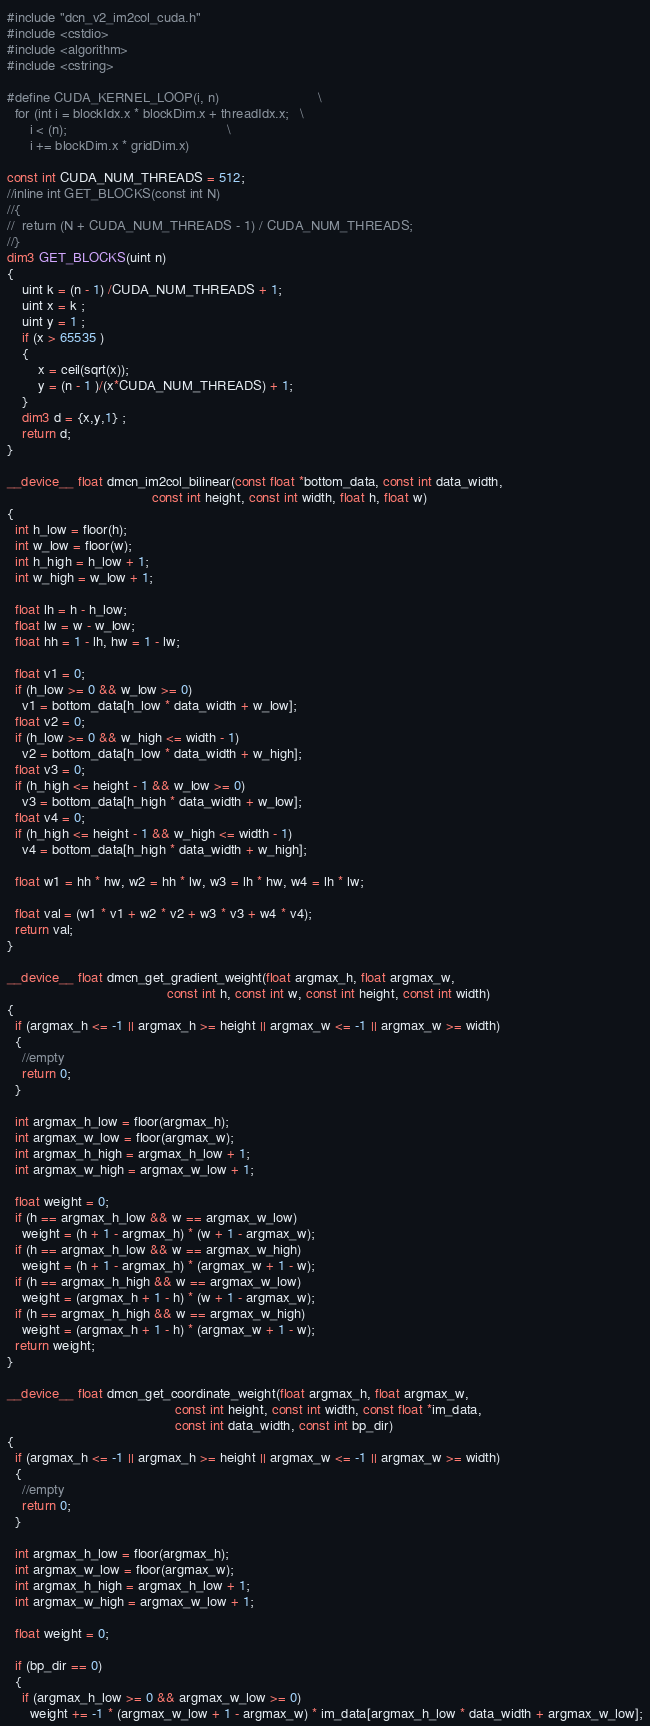Convert code to text. <code><loc_0><loc_0><loc_500><loc_500><_Cuda_>#include "dcn_v2_im2col_cuda.h"
#include <cstdio>
#include <algorithm>
#include <cstring>

#define CUDA_KERNEL_LOOP(i, n)                          \
  for (int i = blockIdx.x * blockDim.x + threadIdx.x;   \
      i < (n);                                          \
      i += blockDim.x * gridDim.x)

const int CUDA_NUM_THREADS = 512;
//inline int GET_BLOCKS(const int N)
//{
//  return (N + CUDA_NUM_THREADS - 1) / CUDA_NUM_THREADS;
//}
dim3 GET_BLOCKS(uint n)
{
    uint k = (n - 1) /CUDA_NUM_THREADS + 1;
    uint x = k ;
    uint y = 1 ;
    if (x > 65535 )
    {
        x = ceil(sqrt(x));
        y = (n - 1 )/(x*CUDA_NUM_THREADS) + 1;
    }
    dim3 d = {x,y,1} ;
    return d;
}

__device__ float dmcn_im2col_bilinear(const float *bottom_data, const int data_width,
                                      const int height, const int width, float h, float w)
{
  int h_low = floor(h);
  int w_low = floor(w);
  int h_high = h_low + 1;
  int w_high = w_low + 1;

  float lh = h - h_low;
  float lw = w - w_low;
  float hh = 1 - lh, hw = 1 - lw;

  float v1 = 0;
  if (h_low >= 0 && w_low >= 0)
    v1 = bottom_data[h_low * data_width + w_low];
  float v2 = 0;
  if (h_low >= 0 && w_high <= width - 1)
    v2 = bottom_data[h_low * data_width + w_high];
  float v3 = 0;
  if (h_high <= height - 1 && w_low >= 0)
    v3 = bottom_data[h_high * data_width + w_low];
  float v4 = 0;
  if (h_high <= height - 1 && w_high <= width - 1)
    v4 = bottom_data[h_high * data_width + w_high];

  float w1 = hh * hw, w2 = hh * lw, w3 = lh * hw, w4 = lh * lw;

  float val = (w1 * v1 + w2 * v2 + w3 * v3 + w4 * v4);
  return val;
}

__device__ float dmcn_get_gradient_weight(float argmax_h, float argmax_w,
                                          const int h, const int w, const int height, const int width)
{
  if (argmax_h <= -1 || argmax_h >= height || argmax_w <= -1 || argmax_w >= width)
  {
    //empty
    return 0;
  }

  int argmax_h_low = floor(argmax_h);
  int argmax_w_low = floor(argmax_w);
  int argmax_h_high = argmax_h_low + 1;
  int argmax_w_high = argmax_w_low + 1;

  float weight = 0;
  if (h == argmax_h_low && w == argmax_w_low)
    weight = (h + 1 - argmax_h) * (w + 1 - argmax_w);
  if (h == argmax_h_low && w == argmax_w_high)
    weight = (h + 1 - argmax_h) * (argmax_w + 1 - w);
  if (h == argmax_h_high && w == argmax_w_low)
    weight = (argmax_h + 1 - h) * (w + 1 - argmax_w);
  if (h == argmax_h_high && w == argmax_w_high)
    weight = (argmax_h + 1 - h) * (argmax_w + 1 - w);
  return weight;
}

__device__ float dmcn_get_coordinate_weight(float argmax_h, float argmax_w,
                                            const int height, const int width, const float *im_data,
                                            const int data_width, const int bp_dir)
{
  if (argmax_h <= -1 || argmax_h >= height || argmax_w <= -1 || argmax_w >= width)
  {
    //empty
    return 0;
  }

  int argmax_h_low = floor(argmax_h);
  int argmax_w_low = floor(argmax_w);
  int argmax_h_high = argmax_h_low + 1;
  int argmax_w_high = argmax_w_low + 1;

  float weight = 0;

  if (bp_dir == 0)
  {
    if (argmax_h_low >= 0 && argmax_w_low >= 0)
      weight += -1 * (argmax_w_low + 1 - argmax_w) * im_data[argmax_h_low * data_width + argmax_w_low];</code> 